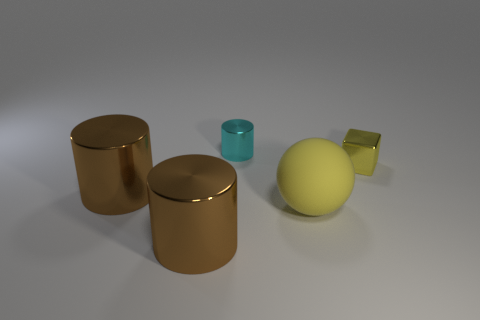Are the big yellow thing and the block made of the same material?
Give a very brief answer. No. There is another metallic object that is the same size as the cyan object; what is its color?
Provide a short and direct response. Yellow. What color is the metallic cylinder that is both in front of the small metallic block and behind the sphere?
Keep it short and to the point. Brown. The metal thing that is the same color as the ball is what size?
Offer a very short reply. Small. There is a matte object that is the same color as the tiny shiny block; what shape is it?
Your answer should be very brief. Sphere. What is the size of the yellow rubber ball that is in front of the large cylinder behind the big brown shiny cylinder in front of the large yellow matte thing?
Keep it short and to the point. Large. What is the tiny cyan cylinder made of?
Offer a terse response. Metal. Is the material of the cyan cylinder the same as the yellow thing left of the tiny yellow metal cube?
Provide a succinct answer. No. Is there anything else that has the same color as the small metallic cube?
Ensure brevity in your answer.  Yes. Are there any shiny blocks behind the small thing in front of the small shiny object that is left of the large ball?
Provide a short and direct response. No. 